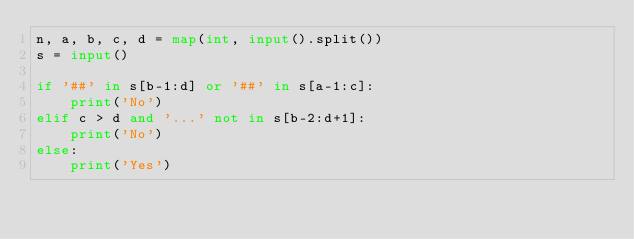Convert code to text. <code><loc_0><loc_0><loc_500><loc_500><_Python_>n, a, b, c, d = map(int, input().split())
s = input()

if '##' in s[b-1:d] or '##' in s[a-1:c]:
    print('No')
elif c > d and '...' not in s[b-2:d+1]:
    print('No')
else:
    print('Yes')
</code> 